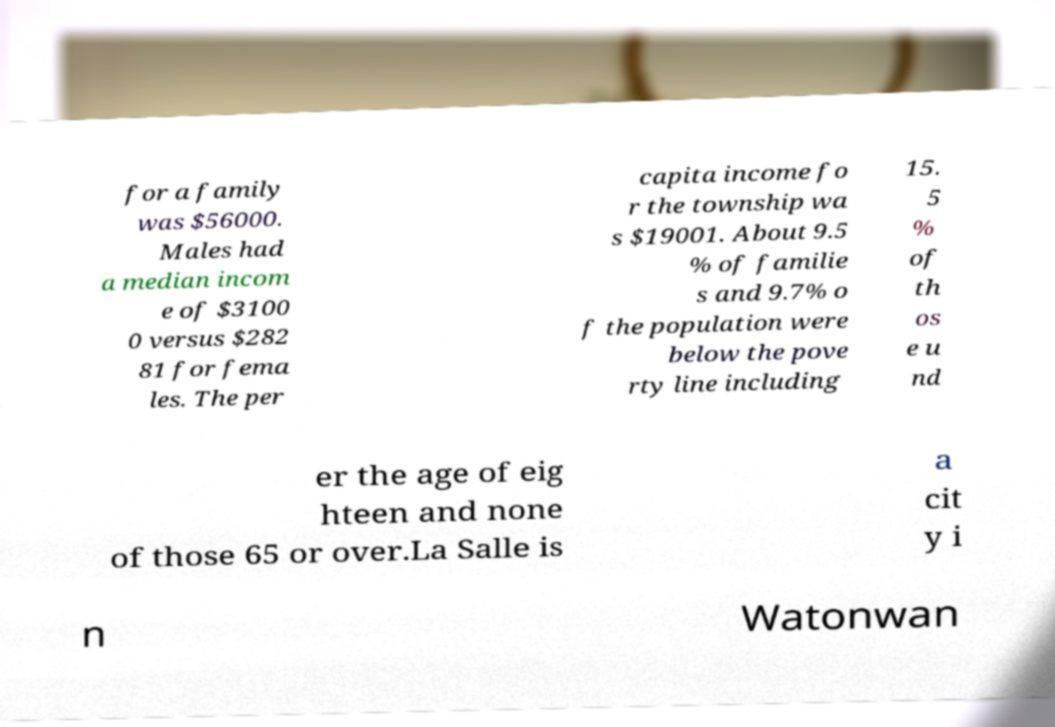Could you assist in decoding the text presented in this image and type it out clearly? for a family was $56000. Males had a median incom e of $3100 0 versus $282 81 for fema les. The per capita income fo r the township wa s $19001. About 9.5 % of familie s and 9.7% o f the population were below the pove rty line including 15. 5 % of th os e u nd er the age of eig hteen and none of those 65 or over.La Salle is a cit y i n Watonwan 